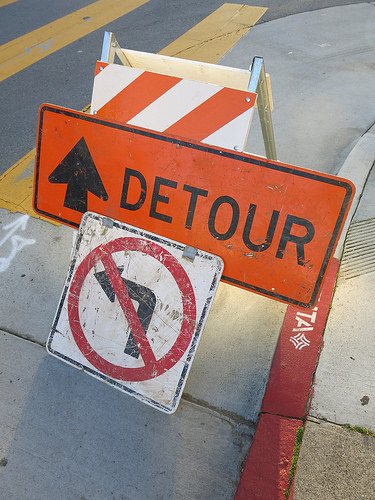<image>
Can you confirm if the sign is above the street? Yes. The sign is positioned above the street in the vertical space, higher up in the scene. 